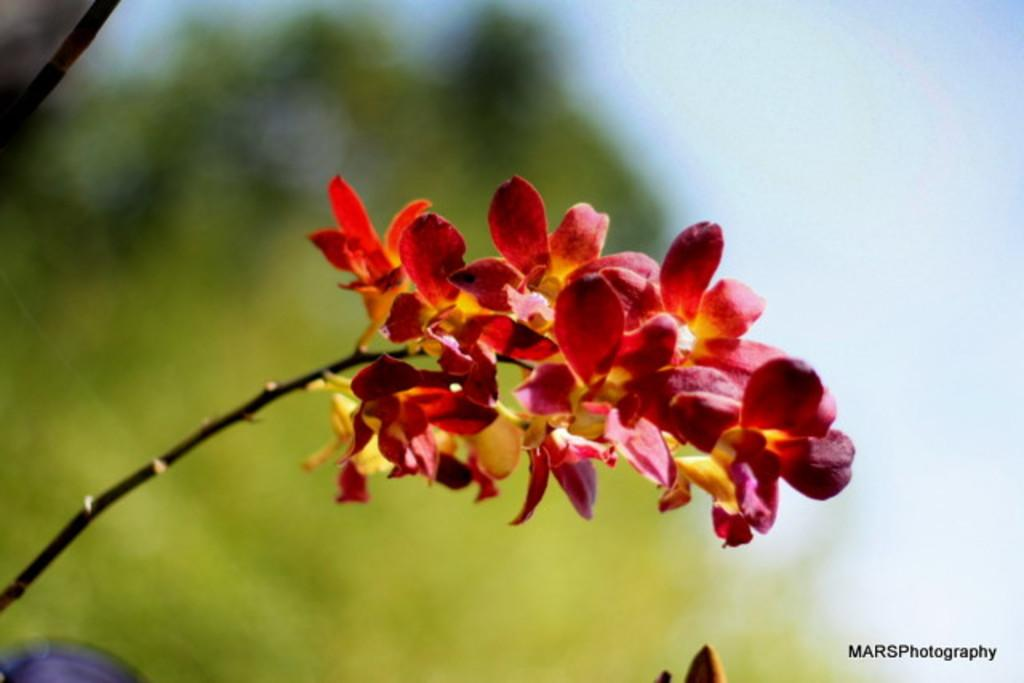What type of living organisms can be seen in the image? There are flowers in the image. How would you describe the background of the image? The background of the image is blurred. Is there any text present in the image? Yes, there is text in the bottom right corner of the image. What type of rice can be seen growing in the image? There is no rice present in the image; it features flowers and a blurred background. What thought is being expressed by the flowers in the image? The flowers are not expressing any thoughts, as they are inanimate objects and cannot think. 